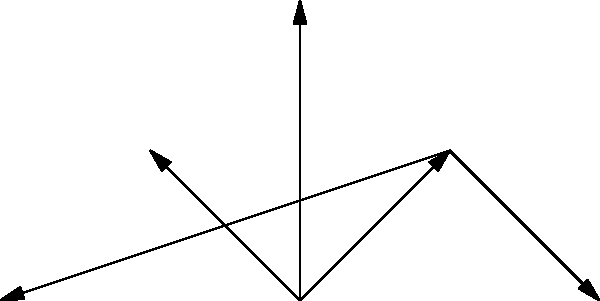Based on the network diagram illustrating methods for analyzing the authenticity of historical documents, which feature is directly connected to both "Ink Analysis" and "Paper Quality"? To answer this question, we need to carefully examine the network diagram and follow these steps:

1. Identify the nodes for "Ink Analysis" and "Paper Quality":
   - "Ink Analysis" is located at the bottom left of the diagram.
   - "Paper Quality" is located at the bottom right of the diagram.

2. Observe the connections:
   - Both "Ink Analysis" and "Paper Quality" are connected to a single node above them.

3. Identify the connecting node:
   - The node directly connected to both "Ink Analysis" and "Paper Quality" is labeled "Physical Features".

4. Verify the relationship:
   - "Physical Features" has arrows pointing towards both "Ink Analysis" and "Paper Quality", indicating a direct connection.

5. Check for any other nodes with similar connections:
   - No other node in the diagram is directly connected to both "Ink Analysis" and "Paper Quality".

Therefore, the feature directly connected to both "Ink Analysis" and "Paper Quality" is "Physical Features".
Answer: Physical Features 